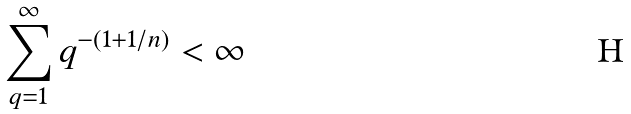Convert formula to latex. <formula><loc_0><loc_0><loc_500><loc_500>\sum _ { q = 1 } ^ { \infty } q ^ { - ( 1 + 1 / n ) } < \infty</formula> 